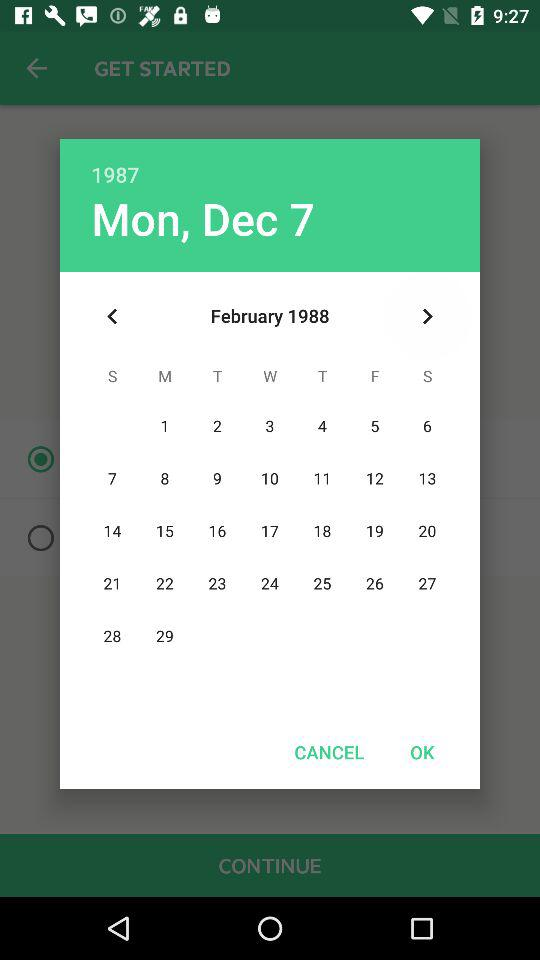What is the mentioned day? The mentioned day is Monday. 